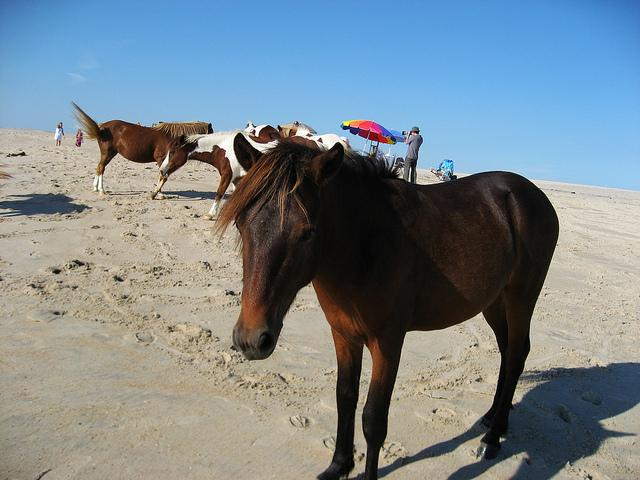How many horses are countable on the beach?

Choices:
A) four
B) two
C) three
D) five five 